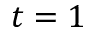Convert formula to latex. <formula><loc_0><loc_0><loc_500><loc_500>t = 1</formula> 